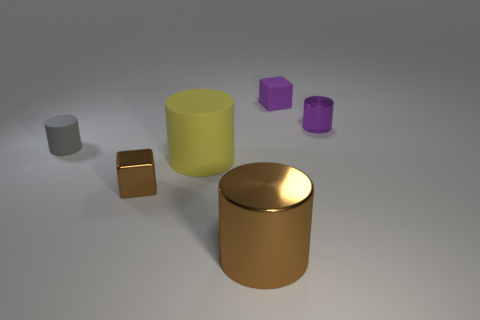Add 3 small gray rubber things. How many objects exist? 9 Subtract all cylinders. How many objects are left? 2 Add 5 big gray shiny cylinders. How many big gray shiny cylinders exist? 5 Subtract 0 cyan spheres. How many objects are left? 6 Subtract all tiny metal cylinders. Subtract all large cylinders. How many objects are left? 3 Add 5 big cylinders. How many big cylinders are left? 7 